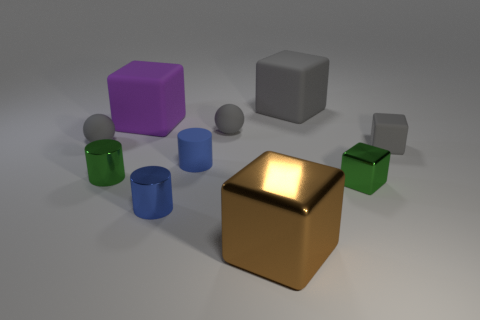How many small objects are gray cubes or matte balls?
Ensure brevity in your answer.  3. Is the size of the metallic cylinder that is in front of the green cube the same as the rubber cylinder?
Make the answer very short. Yes. How many other objects are the same color as the rubber cylinder?
Offer a terse response. 1. What is the material of the large purple cube?
Offer a very short reply. Rubber. There is a thing that is both left of the blue matte thing and in front of the green metal cube; what material is it?
Provide a short and direct response. Metal. What number of objects are tiny green metallic things to the right of the large brown metal thing or large green balls?
Offer a very short reply. 1. Do the rubber cylinder and the tiny shiny block have the same color?
Your answer should be compact. No. Is there a gray ball of the same size as the blue rubber thing?
Offer a very short reply. Yes. How many rubber spheres are both right of the big purple matte thing and to the left of the purple block?
Ensure brevity in your answer.  0. There is a tiny blue shiny cylinder; how many tiny balls are left of it?
Provide a short and direct response. 1. 